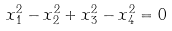Convert formula to latex. <formula><loc_0><loc_0><loc_500><loc_500>x _ { 1 } ^ { 2 } - x _ { 2 } ^ { 2 } + x _ { 3 } ^ { 2 } - x _ { 4 } ^ { 2 } = 0</formula> 